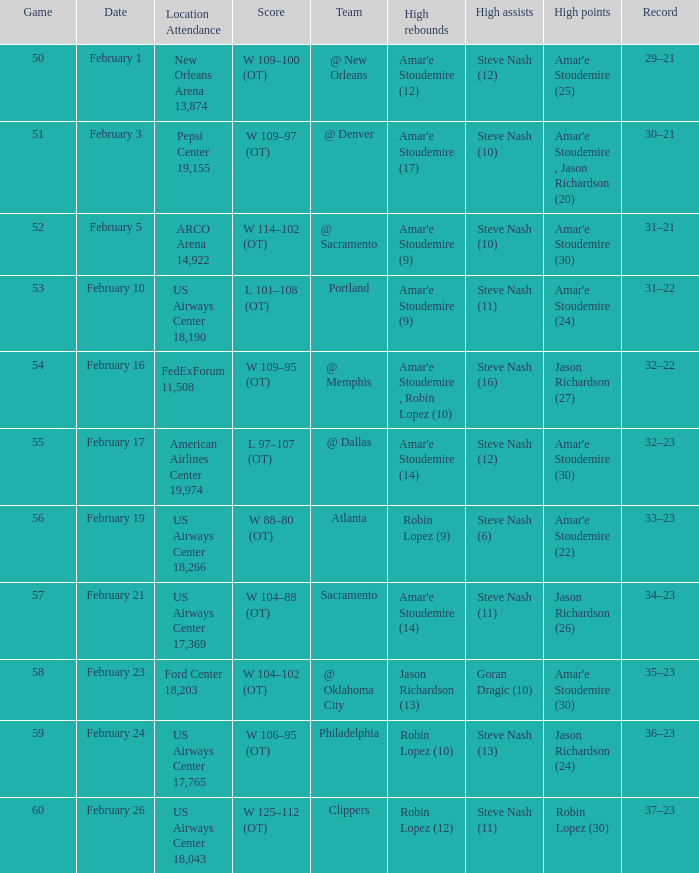Name the high points for pepsi center 19,155 Amar'e Stoudemire , Jason Richardson (20). 